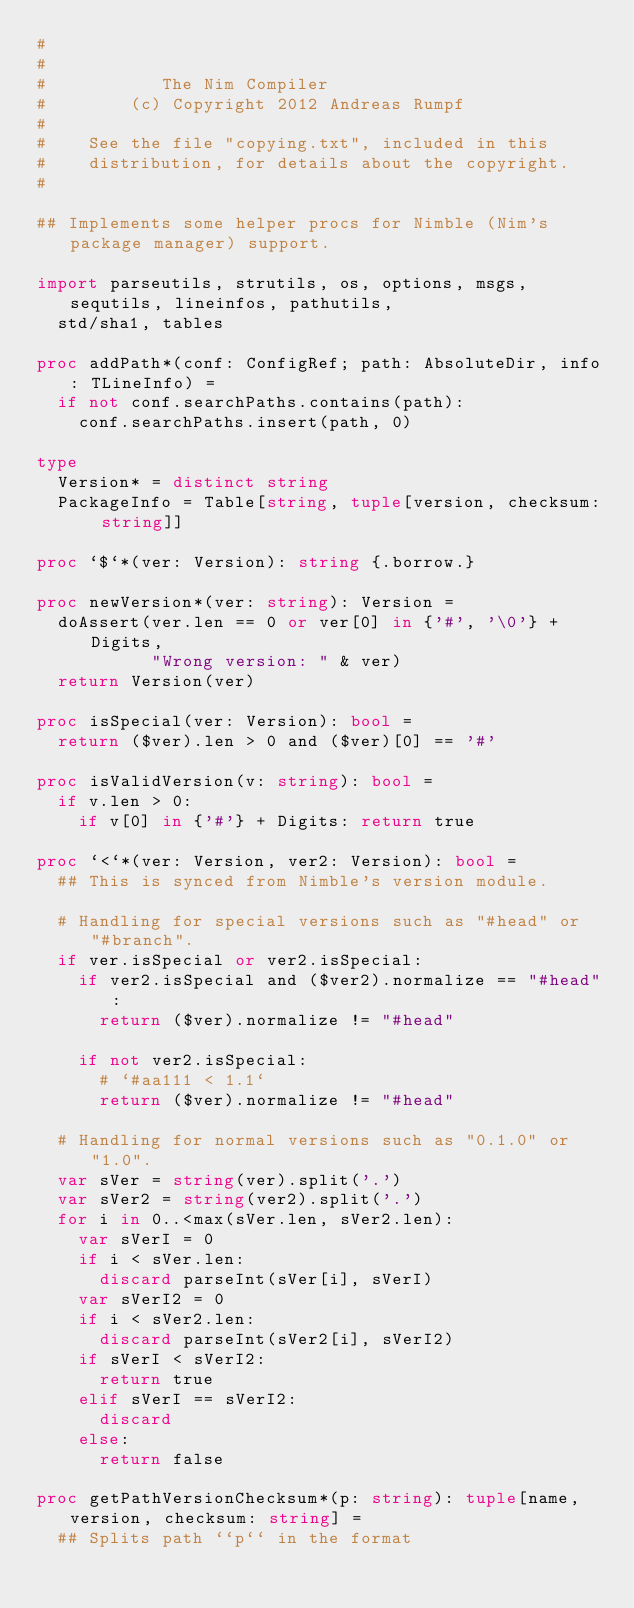Convert code to text. <code><loc_0><loc_0><loc_500><loc_500><_Nim_>#
#
#           The Nim Compiler
#        (c) Copyright 2012 Andreas Rumpf
#
#    See the file "copying.txt", included in this
#    distribution, for details about the copyright.
#

## Implements some helper procs for Nimble (Nim's package manager) support.

import parseutils, strutils, os, options, msgs, sequtils, lineinfos, pathutils,
  std/sha1, tables

proc addPath*(conf: ConfigRef; path: AbsoluteDir, info: TLineInfo) =
  if not conf.searchPaths.contains(path):
    conf.searchPaths.insert(path, 0)

type
  Version* = distinct string
  PackageInfo = Table[string, tuple[version, checksum: string]]

proc `$`*(ver: Version): string {.borrow.}

proc newVersion*(ver: string): Version =
  doAssert(ver.len == 0 or ver[0] in {'#', '\0'} + Digits,
           "Wrong version: " & ver)
  return Version(ver)

proc isSpecial(ver: Version): bool =
  return ($ver).len > 0 and ($ver)[0] == '#'

proc isValidVersion(v: string): bool =
  if v.len > 0:
    if v[0] in {'#'} + Digits: return true

proc `<`*(ver: Version, ver2: Version): bool =
  ## This is synced from Nimble's version module.

  # Handling for special versions such as "#head" or "#branch".
  if ver.isSpecial or ver2.isSpecial:
    if ver2.isSpecial and ($ver2).normalize == "#head":
      return ($ver).normalize != "#head"

    if not ver2.isSpecial:
      # `#aa111 < 1.1`
      return ($ver).normalize != "#head"

  # Handling for normal versions such as "0.1.0" or "1.0".
  var sVer = string(ver).split('.')
  var sVer2 = string(ver2).split('.')
  for i in 0..<max(sVer.len, sVer2.len):
    var sVerI = 0
    if i < sVer.len:
      discard parseInt(sVer[i], sVerI)
    var sVerI2 = 0
    if i < sVer2.len:
      discard parseInt(sVer2[i], sVerI2)
    if sVerI < sVerI2:
      return true
    elif sVerI == sVerI2:
      discard
    else:
      return false

proc getPathVersionChecksum*(p: string): tuple[name, version, checksum: string] =
  ## Splits path ``p`` in the format</code> 